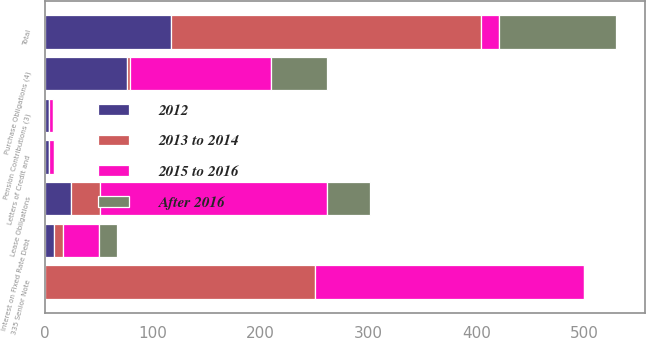<chart> <loc_0><loc_0><loc_500><loc_500><stacked_bar_chart><ecel><fcel>335 Senior Note<fcel>Interest on Fixed Rate Debt<fcel>Lease Obligations<fcel>Letters of Credit and<fcel>Pension Contributions (3)<fcel>Purchase Obligations (4)<fcel>Total<nl><fcel>2015 to 2016<fcel>250<fcel>33.6<fcel>210.4<fcel>4.1<fcel>3.6<fcel>130.6<fcel>16.8<nl><fcel>2012<fcel>0<fcel>8.4<fcel>24.1<fcel>4.1<fcel>3.6<fcel>76.4<fcel>116.6<nl><fcel>After 2016<fcel>0<fcel>16.8<fcel>40.2<fcel>0<fcel>0<fcel>52<fcel>109<nl><fcel>2013 to 2014<fcel>250<fcel>8.4<fcel>26.8<fcel>0<fcel>0<fcel>2.2<fcel>287.4<nl></chart> 